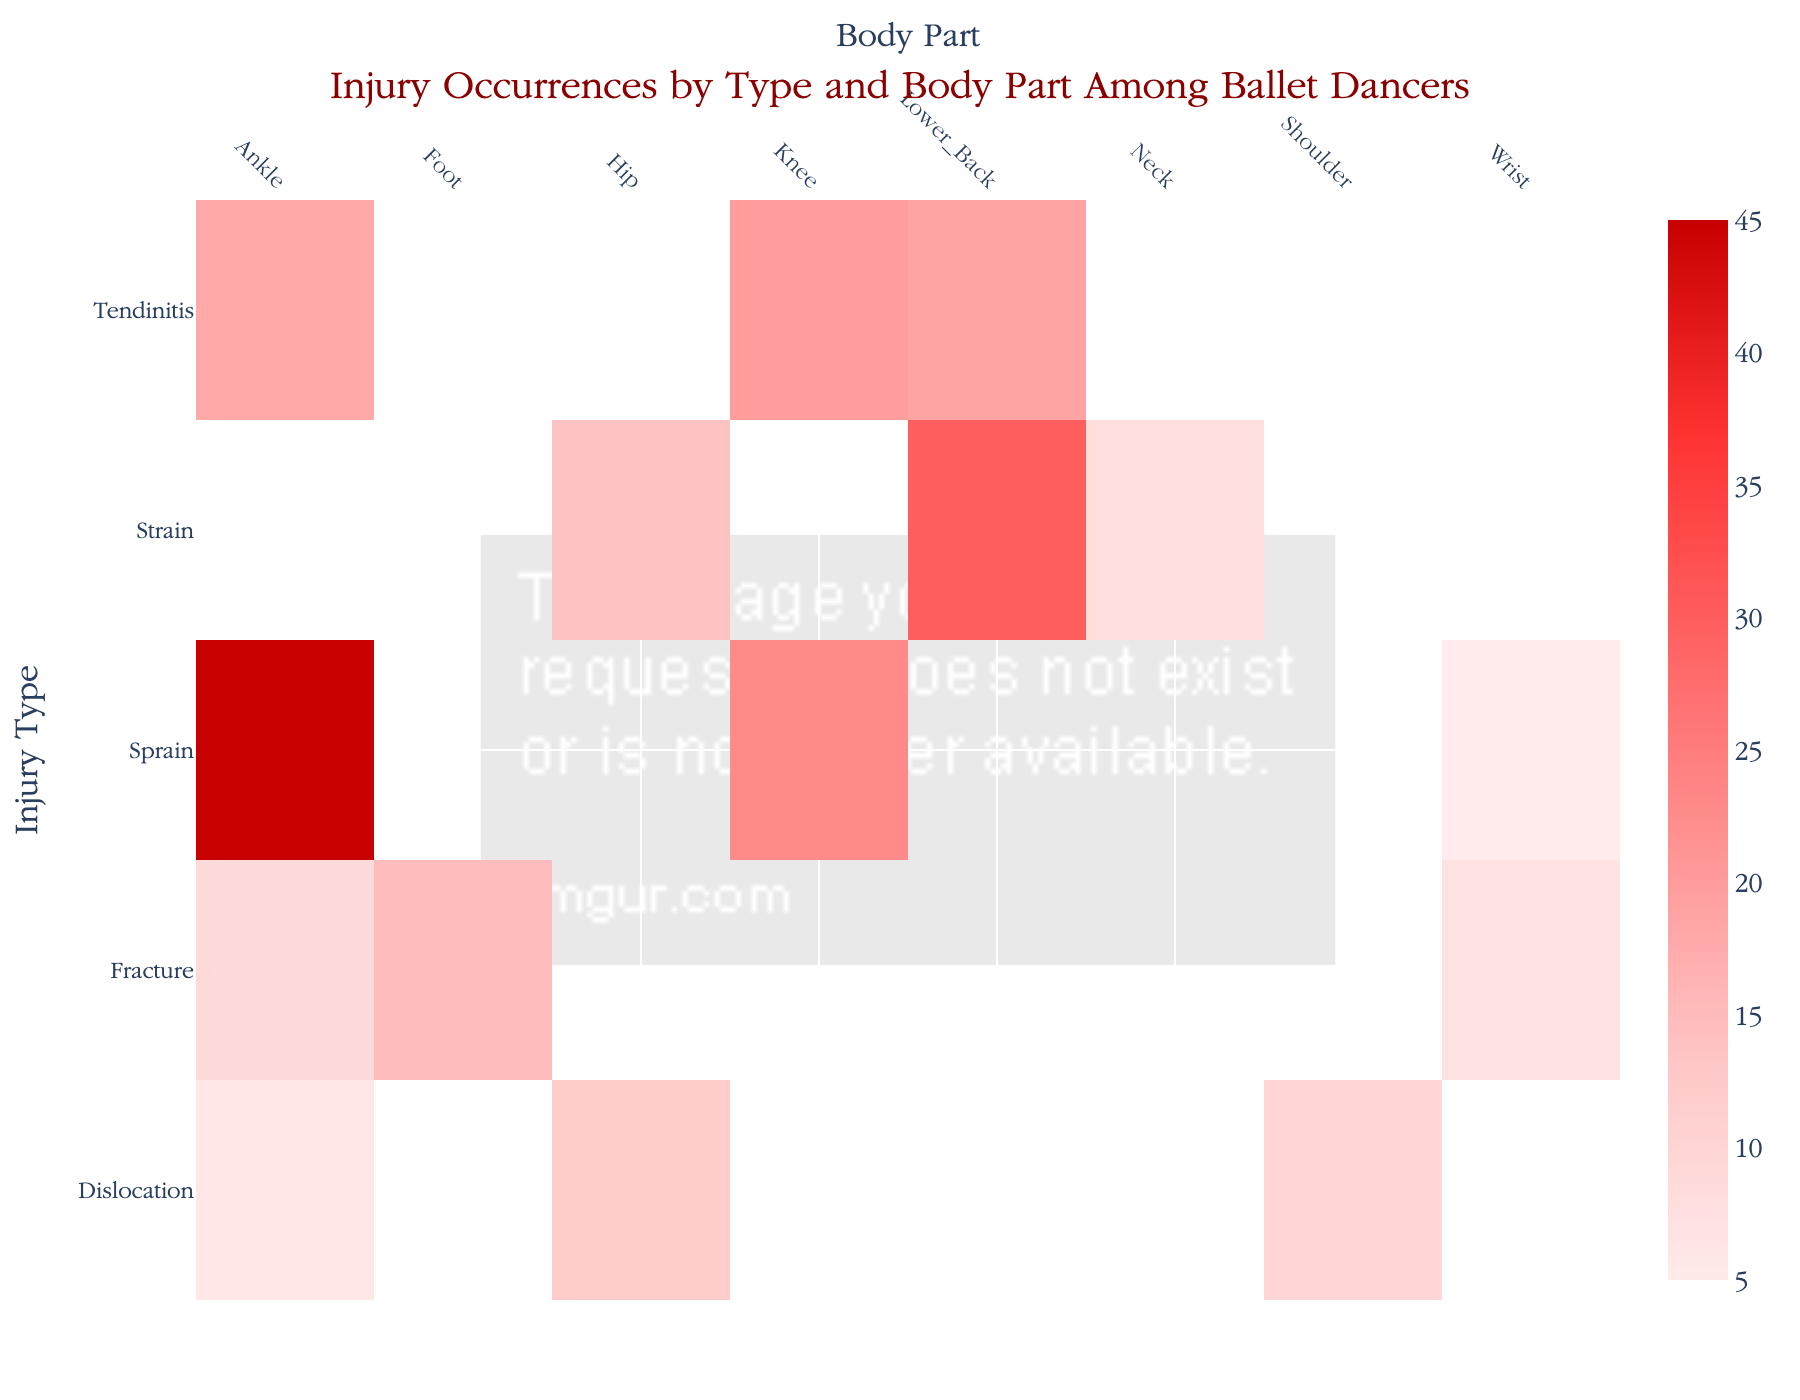What is the title of the heatmap? The title is usually displayed at the top of the heatmap. In this figure, it is written in a large font size and describes the content of the visualization.
Answer: Injury Occurrences by Type and Body Part Among Ballet Dancers Which body part had the highest occurrence of injuries? To find the answer, look for the cell with the deepest red color, indicating the highest number on the color scale used in the heatmap. The body part corresponding to this cell is the answer.
Answer: Ankle How many different injury types are shown on the heatmap? Count the number of distinct labels along the y-axis (left side) of the heatmap. Each label represents a different injury type.
Answer: 5 Which type of injury is the most common for knees? Find the column labeled "Knee" and identify the row with the highest value or the darkest color within that column. The corresponding injury type in that row is the answer.
Answer: Sprain What is the total number of occurrences for Wrist injuries? Sum all the values in the column labeled "Wrist". In this figure, the occurrences are 5 (Sprain) and 7 (Fracture). So, 5 + 7 = 12.
Answer: 12 Which body part has the least total occurrences of injuries, and how many occurrences are there? Check the sum of occurrences for each body part and identify the one with the smallest total. Count the cells within each column and sum their values to find the answer.
Answer: Shoulder, 10 Compare the total occurrences of strains between the Lower Back and the Neck. Which one has a higher total? Find the strain occurrences for Lower_Back and Neck by looking at their respective rows. Lower_Back has 30, and Neck has 8. Thus, Lower_Back has a higher total.
Answer: Lower_Back What is the average occurrence of tendinitis injuries? Sum the occurrences of tendinitis injuries across all body parts and divide by the number of body parts affected. Tendinitis occurrences are 20 (Knee), 18 (Ankle), and 19 (Lower_Back). 20+18+19=57, and there are 3 types of tendinitis. 57/3 = 19.
Answer: 19 Which injury type and body part combination has exactly 6 occurrences? Look for the cell that indicates the number "6" and note both the row (injury type) and the column (body part) labels corresponding to this cell.
Answer: Dislocation, Ankle How many total occurrences of injuries are there for the shoulders and hips combined? Sum up the values in the "Shoulder" and "Hip" columns. For Shoulders: 10. For Hips: 12 (Dislocation) + 14 (Strain). 10 + 12 + 14 = 36.
Answer: 36 